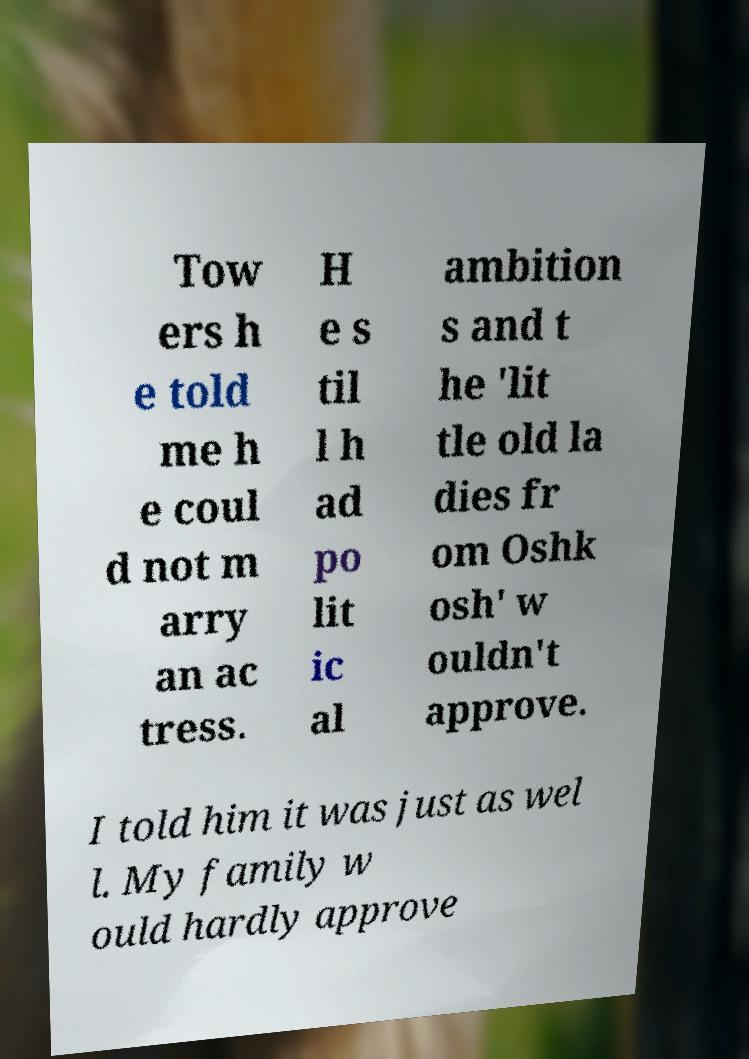Could you extract and type out the text from this image? Tow ers h e told me h e coul d not m arry an ac tress. H e s til l h ad po lit ic al ambition s and t he 'lit tle old la dies fr om Oshk osh' w ouldn't approve. I told him it was just as wel l. My family w ould hardly approve 